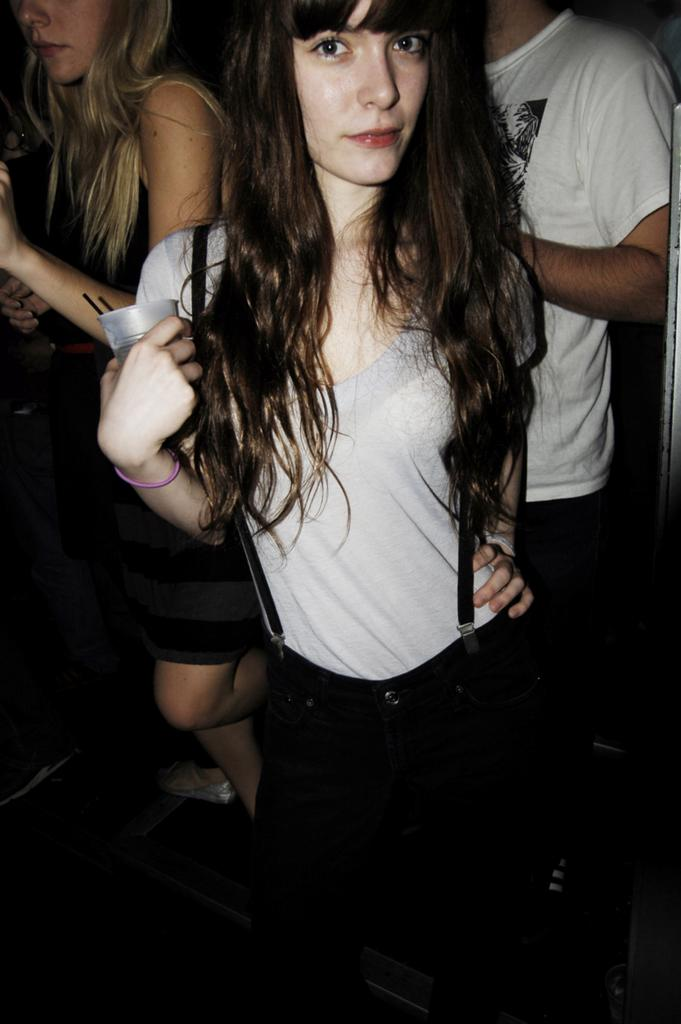Who is the main subject in the image? There is a woman in the image. What is the woman wearing? The woman is wearing a grey t-shirt and black trousers. What is the woman holding in her hand? The woman is holding a cup. What is the woman carrying on her shoulder? The woman is carrying a bag. Are there any other people visible in the image? Yes, there are people visible behind the woman. What type of zinc is present in the image? There is no zinc present in the image. What kind of feast is being prepared by the woman in the image? The image does not show any food preparation or feast; it only shows a woman holding a cup and carrying a bag. 